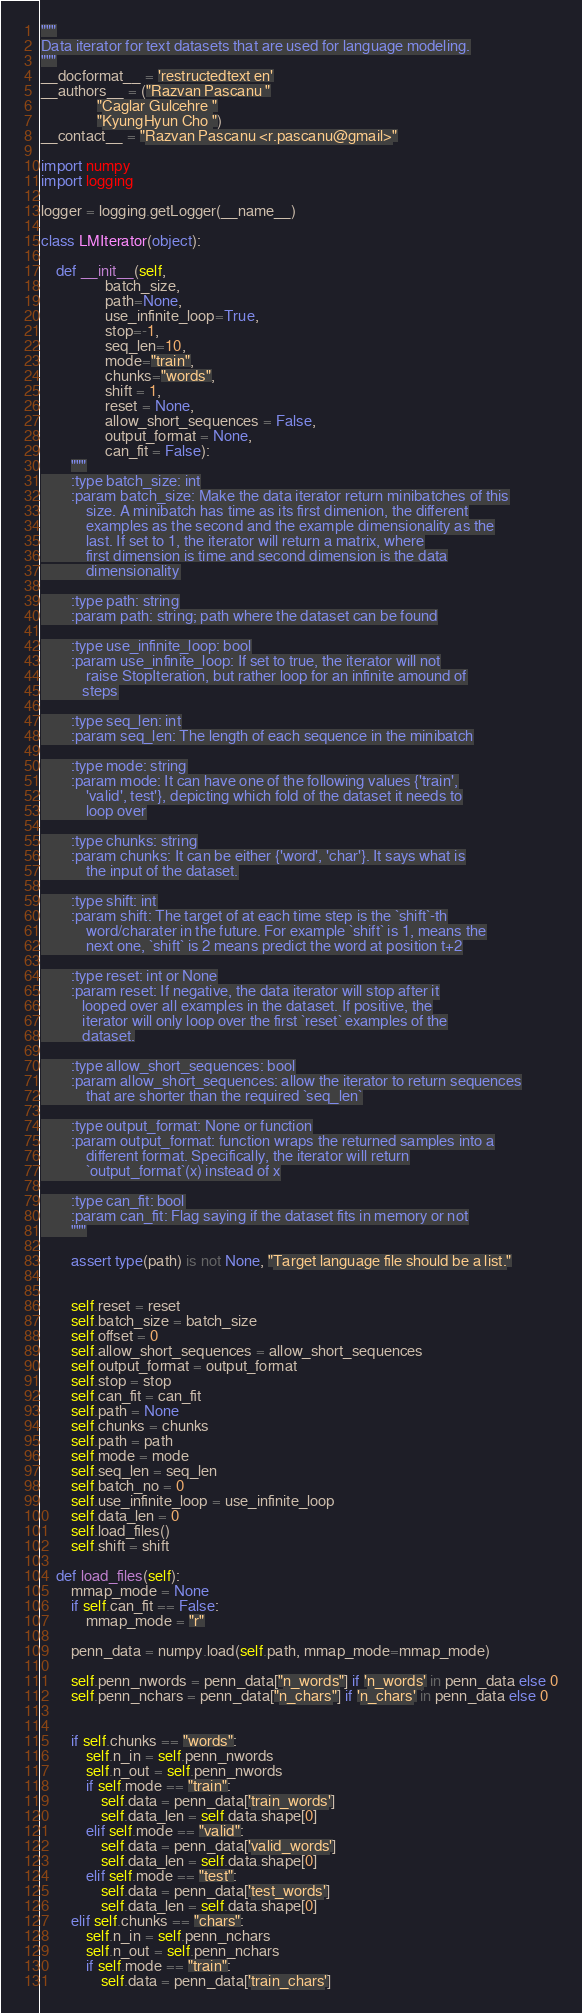Convert code to text. <code><loc_0><loc_0><loc_500><loc_500><_Python_>"""
Data iterator for text datasets that are used for language modeling.
"""
__docformat__ = 'restructedtext en'
__authors__ = ("Razvan Pascanu "
               "Caglar Gulcehre "
               "KyungHyun Cho ")
__contact__ = "Razvan Pascanu <r.pascanu@gmail>"

import numpy
import logging

logger = logging.getLogger(__name__)

class LMIterator(object):

    def __init__(self,
                 batch_size,
                 path=None,
                 use_infinite_loop=True,
                 stop=-1,
                 seq_len=10,
                 mode="train",
                 chunks="words",
                 shift = 1,
                 reset = None,
                 allow_short_sequences = False,
                 output_format = None,
                 can_fit = False):
        """
        :type batch_size: int
        :param batch_size: Make the data iterator return minibatches of this
            size. A minibatch has time as its first dimenion, the different
            examples as the second and the example dimensionality as the
            last. If set to 1, the iterator will return a matrix, where
            first dimension is time and second dimension is the data
            dimensionality

        :type path: string
        :param path: string; path where the dataset can be found

        :type use_infinite_loop: bool
        :param use_infinite_loop: If set to true, the iterator will not
            raise StopIteration, but rather loop for an infinite amound of
           steps

        :type seq_len: int
        :param seq_len: The length of each sequence in the minibatch

        :type mode: string
        :param mode: It can have one of the following values {'train',
            'valid', test'}, depicting which fold of the dataset it needs to
            loop over

        :type chunks: string
        :param chunks: It can be either {'word', 'char'}. It says what is
            the input of the dataset.

        :type shift: int
        :param shift: The target of at each time step is the `shift`-th
            word/charater in the future. For example `shift` is 1, means the
            next one, `shift` is 2 means predict the word at position t+2

        :type reset: int or None
        :param reset: If negative, the data iterator will stop after it
           looped over all examples in the dataset. If positive, the
           iterator will only loop over the first `reset` examples of the
           dataset.

        :type allow_short_sequences: bool
        :param allow_short_sequences: allow the iterator to return sequences
            that are shorter than the required `seq_len`

        :type output_format: None or function
        :param output_format: function wraps the returned samples into a
            different format. Specifically, the iterator will return
            `output_format`(x) instead of x

        :type can_fit: bool
        :param can_fit: Flag saying if the dataset fits in memory or not
        """

        assert type(path) is not None, "Target language file should be a list."


        self.reset = reset
        self.batch_size = batch_size
        self.offset = 0
        self.allow_short_sequences = allow_short_sequences
        self.output_format = output_format
        self.stop = stop
        self.can_fit = can_fit
        self.path = None
        self.chunks = chunks
        self.path = path
        self.mode = mode
        self.seq_len = seq_len
        self.batch_no = 0
        self.use_infinite_loop = use_infinite_loop
        self.data_len = 0
        self.load_files()
        self.shift = shift

    def load_files(self):
        mmap_mode = None
        if self.can_fit == False:
            mmap_mode = "r"

        penn_data = numpy.load(self.path, mmap_mode=mmap_mode)

        self.penn_nwords = penn_data["n_words"] if 'n_words' in penn_data else 0
        self.penn_nchars = penn_data["n_chars"] if 'n_chars' in penn_data else 0


        if self.chunks == "words":
            self.n_in = self.penn_nwords
            self.n_out = self.penn_nwords
            if self.mode == "train":
                self.data = penn_data['train_words']
                self.data_len = self.data.shape[0]
            elif self.mode == "valid":
                self.data = penn_data['valid_words']
                self.data_len = self.data.shape[0]
            elif self.mode == "test":
                self.data = penn_data['test_words']
                self.data_len = self.data.shape[0]
        elif self.chunks == "chars":
            self.n_in = self.penn_nchars
            self.n_out = self.penn_nchars
            if self.mode == "train":
                self.data = penn_data['train_chars']</code> 